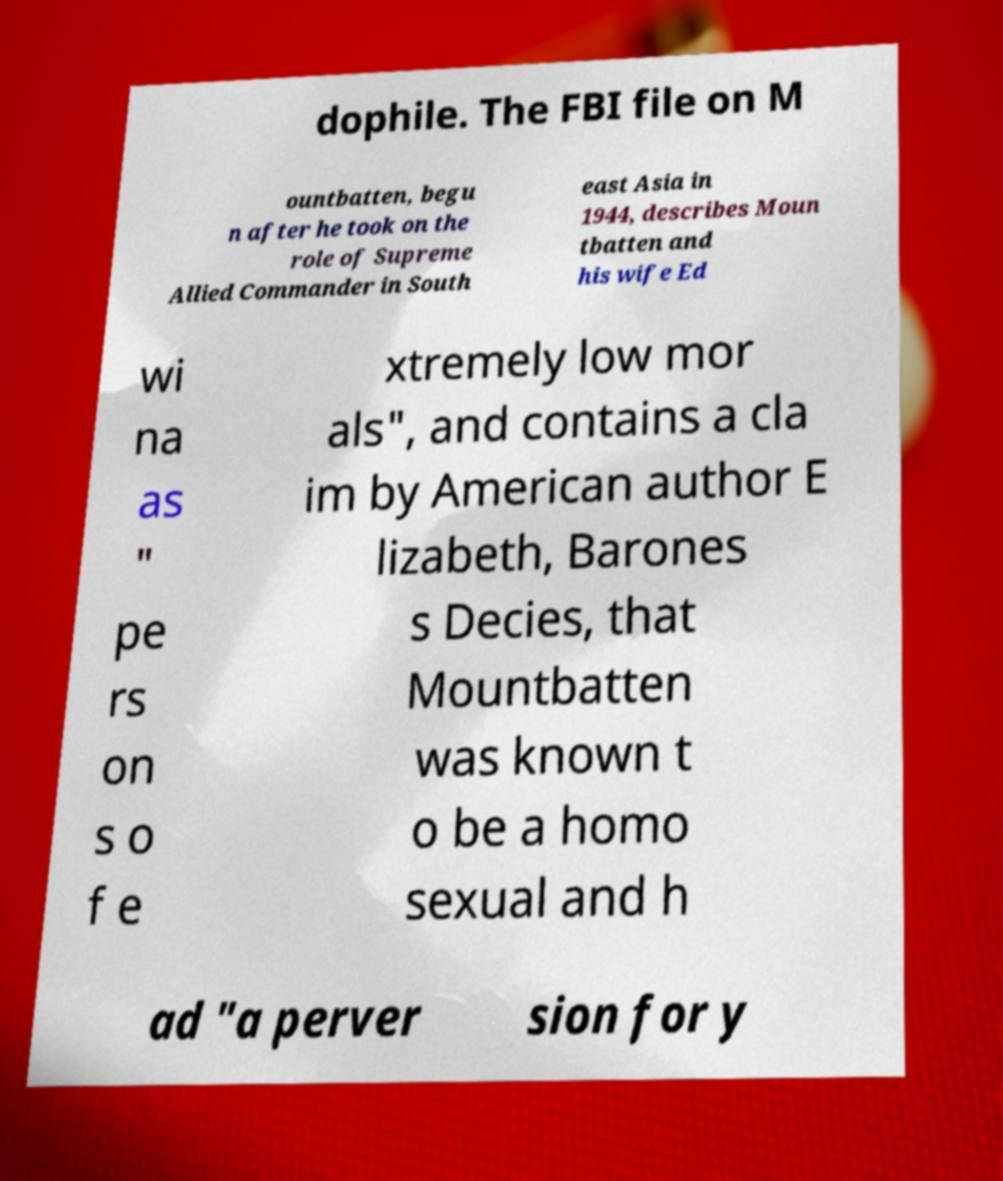Could you assist in decoding the text presented in this image and type it out clearly? dophile. The FBI file on M ountbatten, begu n after he took on the role of Supreme Allied Commander in South east Asia in 1944, describes Moun tbatten and his wife Ed wi na as " pe rs on s o f e xtremely low mor als", and contains a cla im by American author E lizabeth, Barones s Decies, that Mountbatten was known t o be a homo sexual and h ad "a perver sion for y 